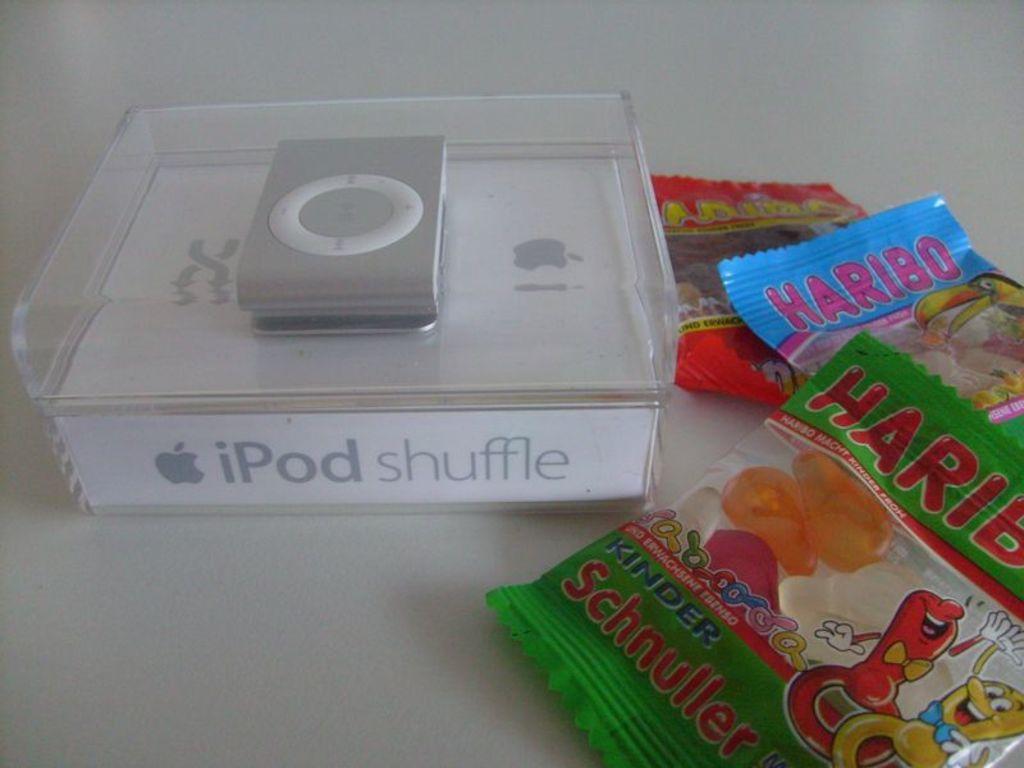Can you describe this image briefly? In this picture I can see the iPod in a plastic box. Beside that I can see the plastic covers which are kept on the table. 